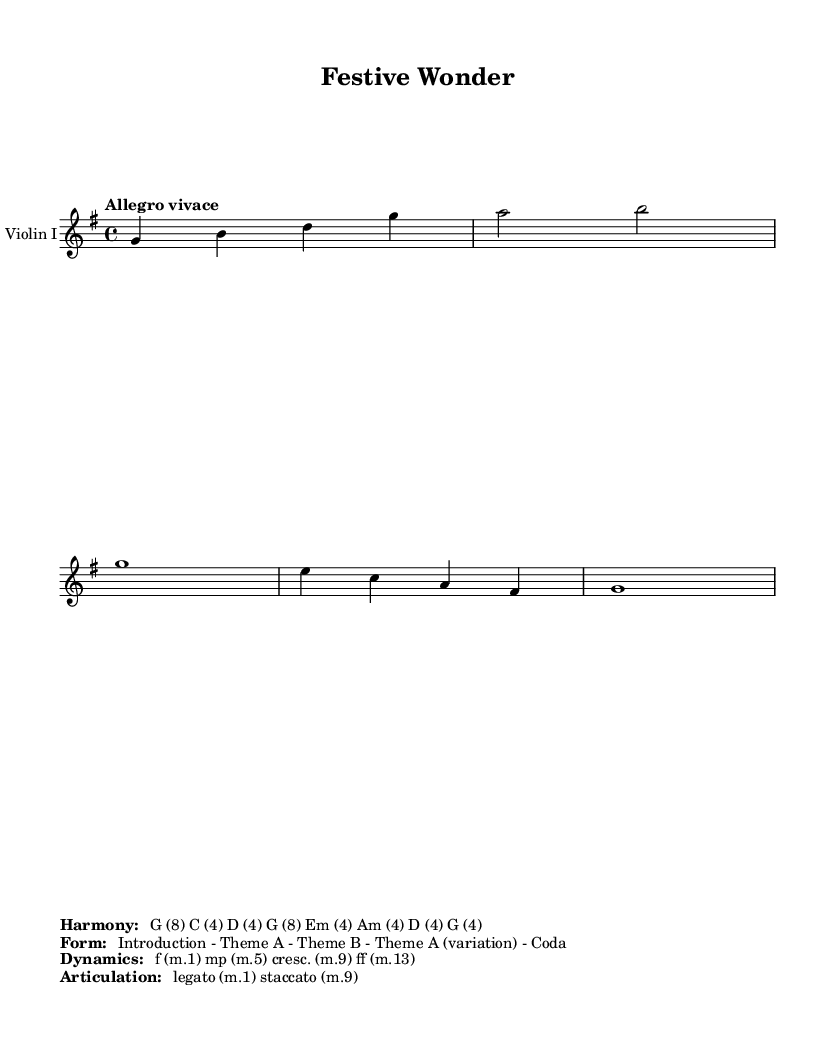What is the title of the piece? The title can be found in the header of the sheet music. It is labeled as "Festive Wonder".
Answer: Festive Wonder What is the key signature of this music? The key signature is indicated by the key signature symbol at the beginning of the piece. It shows one sharp which indicates G major.
Answer: G major What is the time signature of this music? The time signature is indicated right after the key signature. It is 4/4, meaning there are four beats in a measure.
Answer: 4/4 What is the tempo marking for this piece? The tempo is specified at the beginning of the score. The notation shows "Allegro vivace", indicating a fast and lively speed.
Answer: Allegro vivace How many themes are in the structure of the piece? The structure list suggests that there are three distinct themes identified in the form: Theme A, Theme B, and Theme A (variation).
Answer: Three What dynamics are indicated at the beginning of the piece? The dynamics are shown with the symbols 'f' for forte at measure one and 'mp' for mezzo-piano at measure five, signaling the loudness of the music.
Answer: f, mp Which articulation is used at measure nine? The articulation is noted at measure nine in the dynamics section, where 'staccato' is indicated, meaning to play the notes short and detached.
Answer: Staccato 